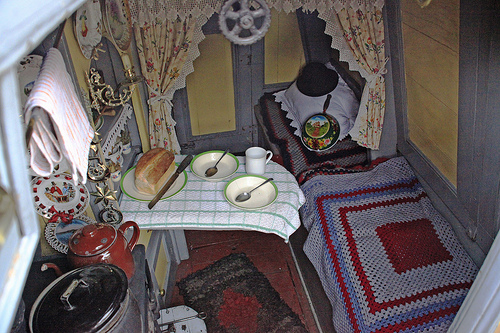<image>
Is there a bread above the knife? No. The bread is not positioned above the knife. The vertical arrangement shows a different relationship. Is the bread behind the knife? No. The bread is not behind the knife. From this viewpoint, the bread appears to be positioned elsewhere in the scene. 